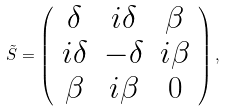Convert formula to latex. <formula><loc_0><loc_0><loc_500><loc_500>\tilde { S } = \left ( \begin{array} { c c c } \delta & i \delta & \beta \\ i \delta & - \delta & i \beta \\ \beta & i \beta & 0 \end{array} \right ) ,</formula> 